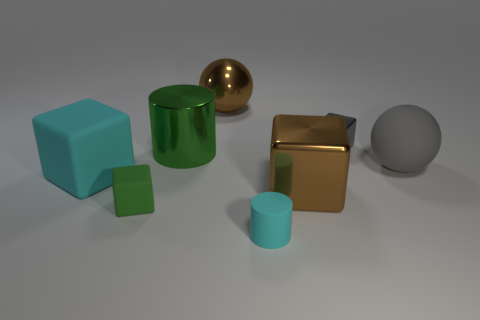There is a thing that is the same color as the large cylinder; what is its shape?
Make the answer very short. Cube. There is a cyan matte block; is it the same size as the metal block that is behind the gray rubber sphere?
Your response must be concise. No. There is a small object that is both to the right of the small green block and behind the rubber cylinder; what is its color?
Give a very brief answer. Gray. Are there more large brown metallic things right of the metallic ball than tiny matte cylinders behind the tiny gray block?
Keep it short and to the point. Yes. What size is the other cube that is the same material as the green block?
Keep it short and to the point. Large. There is a big thing that is behind the metal cylinder; how many rubber objects are right of it?
Your answer should be very brief. 2. Are there any gray metallic things that have the same shape as the small green matte object?
Keep it short and to the point. Yes. The large block that is to the right of the cyan thing that is on the left side of the small green rubber object is what color?
Offer a very short reply. Brown. Is the number of cylinders greater than the number of big cyan metal objects?
Your response must be concise. Yes. What number of metal cubes are the same size as the green rubber object?
Your answer should be compact. 1. 